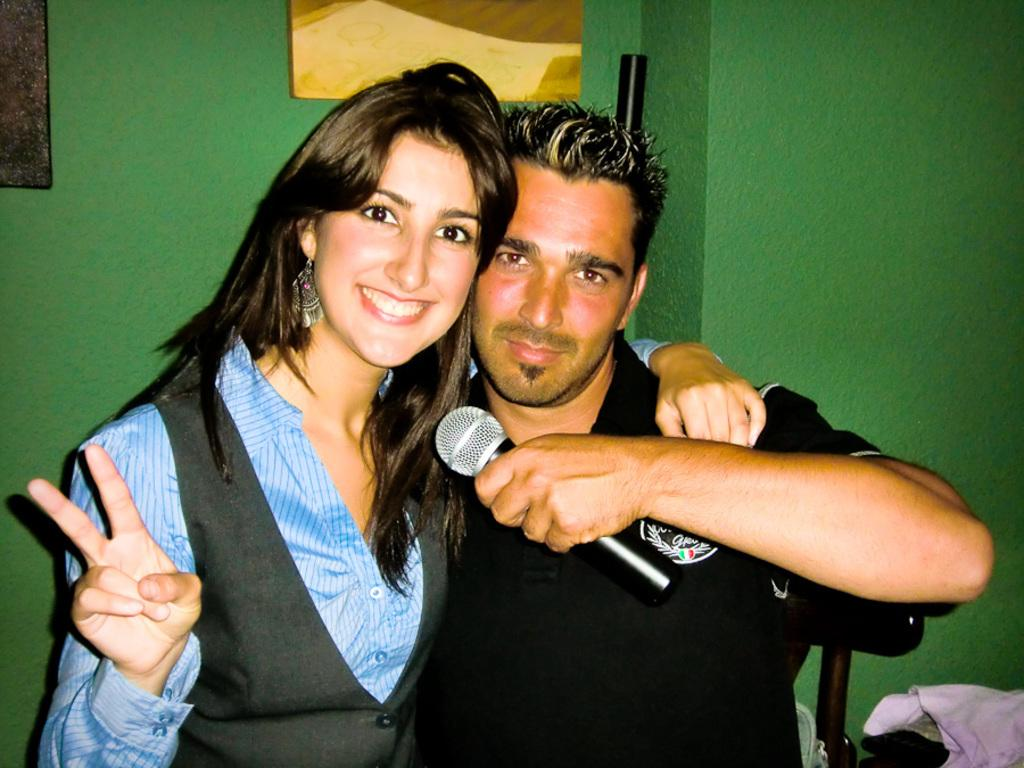What is the man in the image holding? The man is holding a mic in the image. Can you describe the woman's expression in the image? The woman is smiling in the image. What type of marble is present in the image? There is no marble present in the image. How does the man in the image attract the attention of the audience? The image does not show the man interacting with an audience, so it cannot be determined how he attracts their attention. 